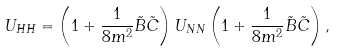<formula> <loc_0><loc_0><loc_500><loc_500>U _ { H H } = \left ( 1 + \frac { 1 } { 8 m ^ { 2 } } \tilde { B } \tilde { C } \right ) U _ { N N } \left ( 1 + \frac { 1 } { 8 m ^ { 2 } } \tilde { B } \tilde { C } \right ) ,</formula> 